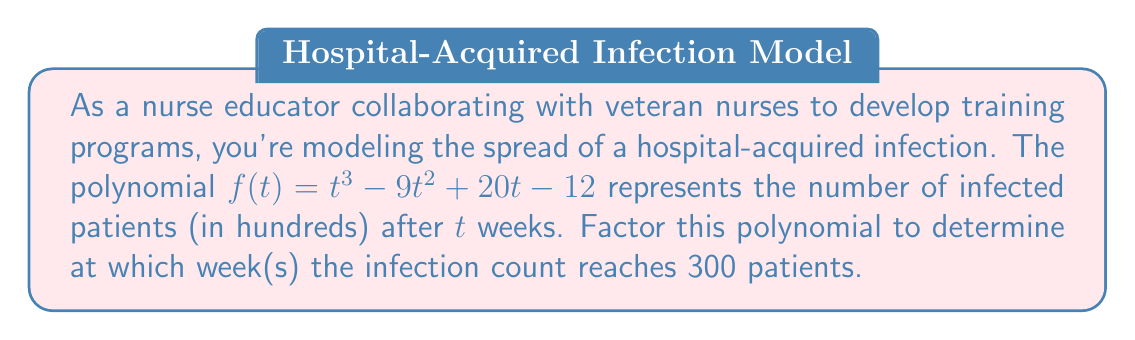Could you help me with this problem? To solve this problem, we need to follow these steps:

1) First, we need to factor the polynomial $f(t) = t^3 - 9t^2 + 20t - 12$

2) We can use the rational root theorem to find potential roots. The factors of the constant term (-12) are ±1, ±2, ±3, ±4, ±6, ±12

3) Testing these, we find that $t=1$ is a root. So $(t-1)$ is a factor.

4) Dividing $f(t)$ by $(t-1)$:
   $t^3 - 9t^2 + 20t - 12 = (t-1)(t^2 - 8t + 12)$

5) Now we need to factor $t^2 - 8t + 12$
   This is a quadratic that can be factored as $(t-6)(t-2)$

6) So, the fully factored polynomial is:
   $f(t) = (t-1)(t-6)(t-2)$

7) We're looking for when the infection count reaches 300 patients, which is 3 hundreds. So we need to solve:
   $f(t) = 3$
   $(t-1)(t-6)(t-2) = 3$

8) The left side equals 3 when $t=1$, $t=6$, or $t=2$

Therefore, the infection count reaches 300 patients at 1 week, 2 weeks, and 6 weeks.
Answer: 1, 2, and 6 weeks 